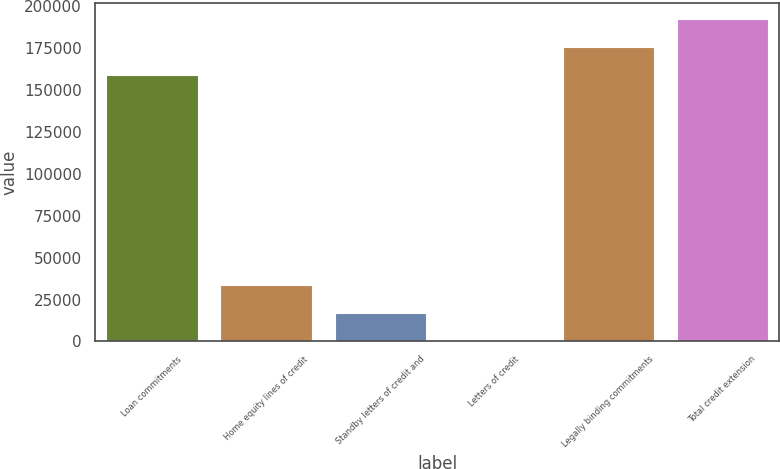<chart> <loc_0><loc_0><loc_500><loc_500><bar_chart><fcel>Loan commitments<fcel>Home equity lines of credit<fcel>Standby letters of credit and<fcel>Letters of credit<fcel>Legally binding commitments<fcel>Total credit extension<nl><fcel>158920<fcel>33744.2<fcel>17001.1<fcel>258<fcel>175663<fcel>192406<nl></chart> 